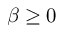Convert formula to latex. <formula><loc_0><loc_0><loc_500><loc_500>\beta \geq 0</formula> 